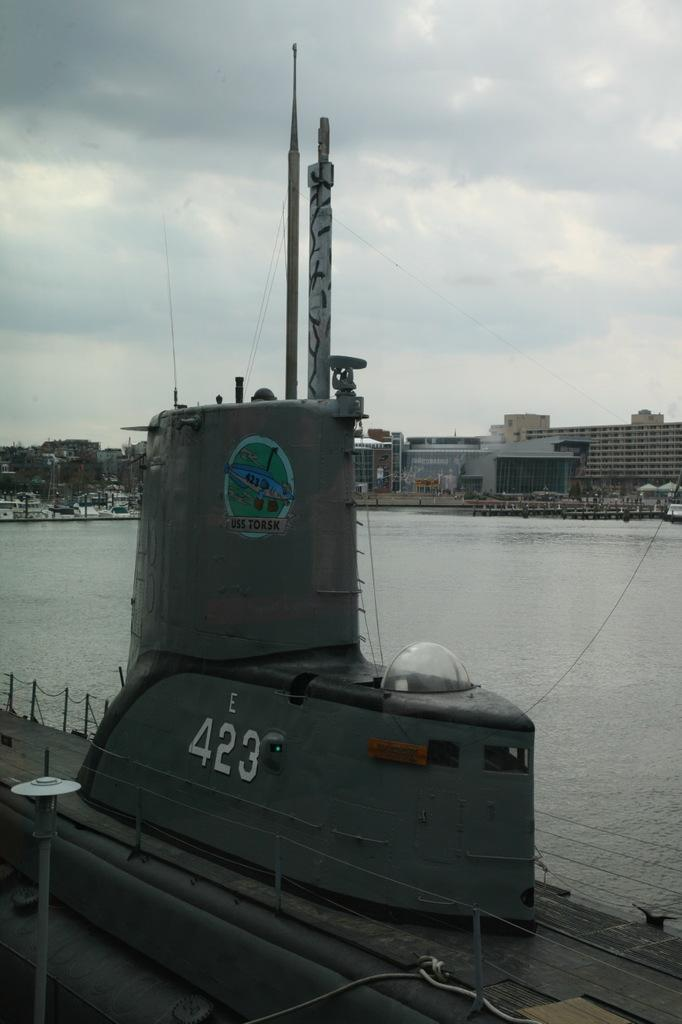What is the main subject of the picture? The main subject of the picture is a submarine. What can be seen in the background of the picture? There is water and buildings visible in the background of the picture. What is the condition of the sky in the picture? The sky is clear in the picture. Can you tell me how many dinosaurs are swimming alongside the submarine in the image? There are no dinosaurs present in the image; it features a submarine in the water. What type of learning activity is taking place in the image? There is no learning activity depicted in the image; it shows a submarine in the water with a clear sky. 